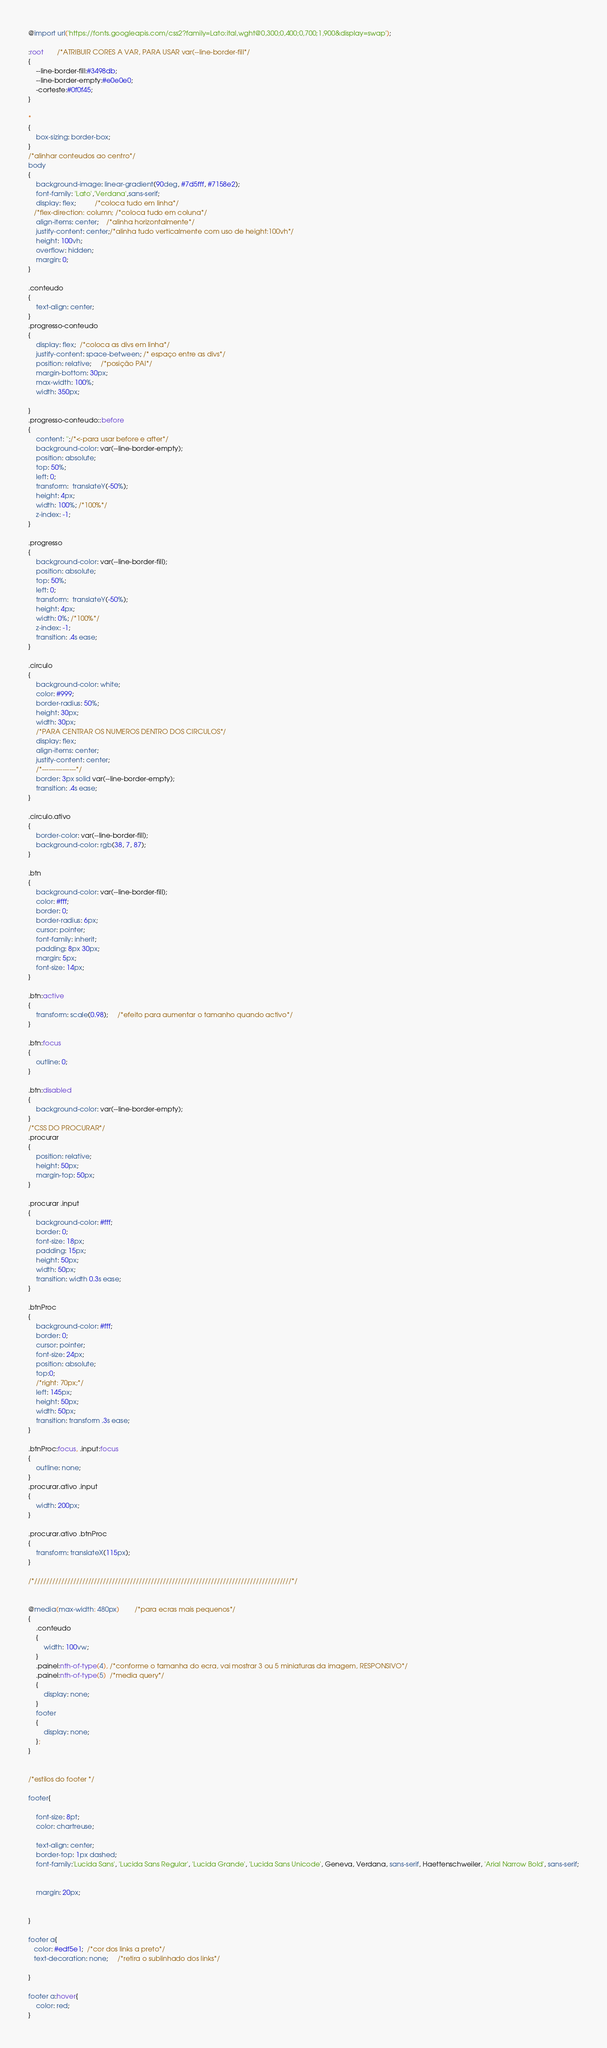Convert code to text. <code><loc_0><loc_0><loc_500><loc_500><_CSS_>@import url('https://fonts.googleapis.com/css2?family=Lato:ital,wght@0,300;0,400;0,700;1,900&display=swap');

:root       /*ATRIBUIR CORES A VAR, PARA USAR var(--line-border-fill*/
{
    --line-border-fill:#3498db;
    --line-border-empty:#e0e0e0;
    -corteste:#0f0f45;
}

* 
{
    box-sizing: border-box;
}
/*alinhar conteudos ao centro*/
body
{
    background-image: linear-gradient(90deg, #7d5fff, #7158e2);
    font-family: 'Lato','Verdana',sans-serif;
    display: flex;          /*coloca tudo em linha*/
   /*flex-direction: column; /*coloca tudo em coluna*/
    align-items: center;    /*alinha horizontalmente*/
    justify-content: center;/*alinha tudo verticalmente com uso de height:100vh*/
    height: 100vh;
    overflow: hidden;
    margin: 0;
}

.conteudo
{
    text-align: center;
}
.progresso-conteudo
{
    display: flex;  /*coloca as divs em linha*/
    justify-content: space-between; /* espaço entre as divs*/
    position: relative;     /*posição PAI*/
    margin-bottom: 30px;
    max-width: 100%;
    width: 350px;

}
.progresso-conteudo::before
{
    content: '';/*<-para usar before e after*/
    background-color: var(--line-border-empty);
    position: absolute;
    top: 50%;
    left: 0;
    transform:  translateY(-50%);
    height: 4px;
    width: 100%; /*100%*/
    z-index: -1;
}

.progresso 
{
    background-color: var(--line-border-fill);
    position: absolute;
    top: 50%;
    left: 0;
    transform:  translateY(-50%);
    height: 4px;
    width: 0%; /*100%*/
    z-index: -1;
    transition: .4s ease;
}

.circulo
{
    background-color: white;
    color: #999;
    border-radius: 50%;
    height: 30px;
    width: 30px;
    /*PARA CENTRAR OS NUMEROS DENTRO DOS CIRCULOS*/
    display: flex;
    align-items: center;
    justify-content: center;
    /*---------------*/
    border: 3px solid var(--line-border-empty);
    transition: .4s ease;
}

.circulo.ativo
{
    border-color: var(--line-border-fill);
    background-color: rgb(38, 7, 87);
}

.btn
{
    background-color: var(--line-border-fill);
    color: #fff;
    border: 0;
    border-radius: 6px;
    cursor: pointer;
    font-family: inherit;
    padding: 8px 30px;
    margin: 5px;
    font-size: 14px;
}

.btn:active
{
    transform: scale(0.98);     /*efeito para aumentar o tamanho quando activo*/
}

.btn:focus
{
    outline: 0;
}

.btn:disabled
{
    background-color: var(--line-border-empty);
}
/*CSS DO PROCURAR*/
.procurar
{
    position: relative;
    height: 50px;
    margin-top: 50px;
}

.procurar .input
{
    background-color: #fff;
    border: 0;
    font-size: 18px;
    padding: 15px;
    height: 50px;
    width: 50px;
    transition: width 0.3s ease;
}

.btnProc
{
    background-color: #fff;
    border: 0;
    cursor: pointer;
    font-size: 24px;
    position: absolute;
    top:0;
    /*right: 70px;*/
    left: 145px;
    height: 50px;
    width: 50px;
    transition: transform .3s ease;
}

.btnProc:focus, .input:focus 
{
    outline: none;
}
.procurar.ativo .input 
{
    width: 200px;
}

.procurar.ativo .btnProc 
{
    transform: translateX(115px);
}

/*//////////////////////////////////////////////////////////////////////////////////////*/


@media(max-width: 480px)        /*para ecras mais pequenos*/
{
    .conteudo
    {
        width: 100vw;
    }
    .painel:nth-of-type(4), /*conforme o tamanha do ecra, vai mostrar 3 ou 5 miniaturas da imagem, RESPONSIVO*/
    .painel:nth-of-type(5)  /*media query*/
    {
        display: none;
    }
    footer 
    {
        display: none;
    };
}


/*estilos do footer */

footer{
    
    font-size: 8pt;
    color: chartreuse;
    
    text-align: center;
    border-top: 1px dashed;
    font-family:'Lucida Sans', 'Lucida Sans Regular', 'Lucida Grande', 'Lucida Sans Unicode', Geneva, Verdana, sans-serif, Haettenschweiler, 'Arial Narrow Bold', sans-serif;
    
   
    margin: 20px;
    
    
}

footer a{
   color: #edf5e1;  /*cor dos links a preto*/
   text-decoration: none;     /*retira o sublinhado dos links*/
  
}

footer a:hover{
    color: red;
}


</code> 